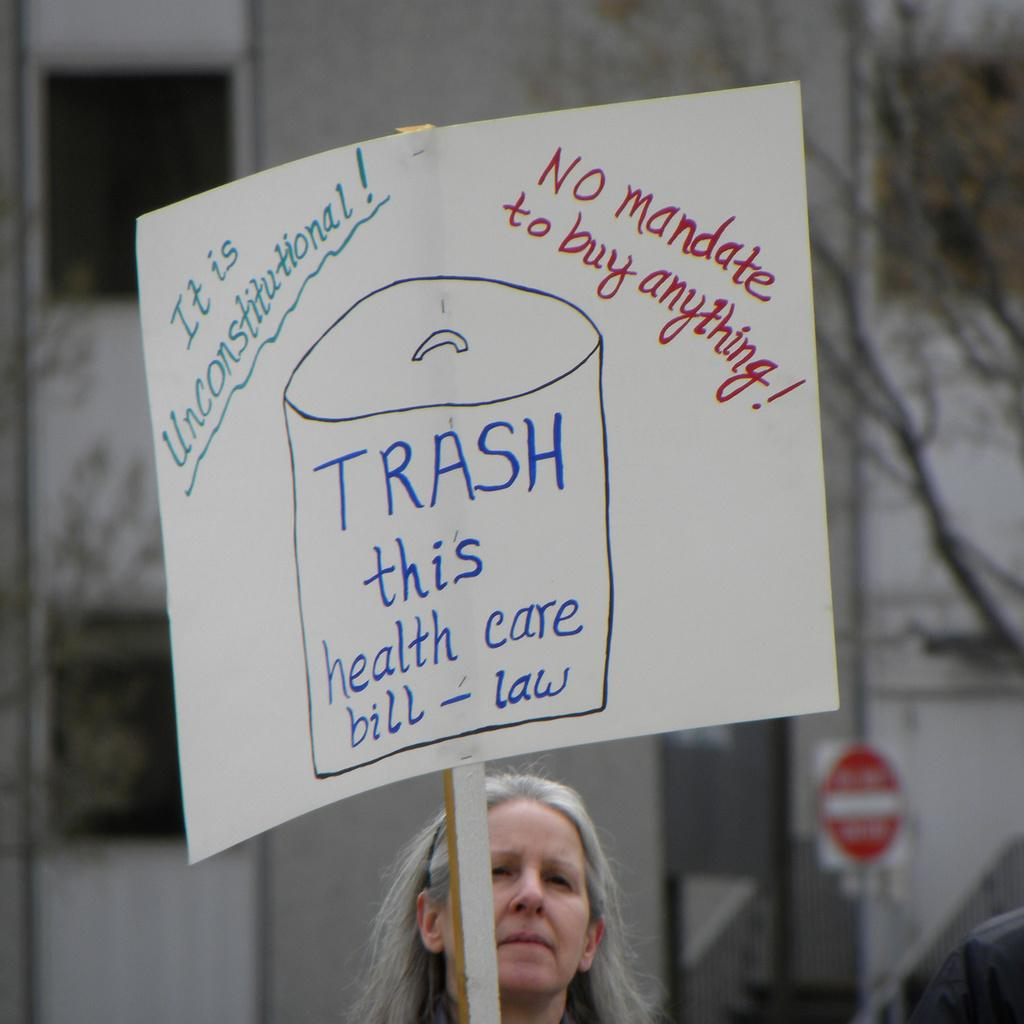Who is the main subject in the foreground of the image? There is a lady in the foreground of the image. What is the lady holding in the image? The lady is holding a placard. What can be read on the placard? There are texts on the placard. What can be seen in the background of the image? There are buildings, trees, and a sign board in the background of the image. What riddle does the lady's grandmother tell her in the image? There is no mention of a grandmother or a riddle in the image. The lady is holding a placard with texts, but there is no indication of a riddle or any conversation taking place. 